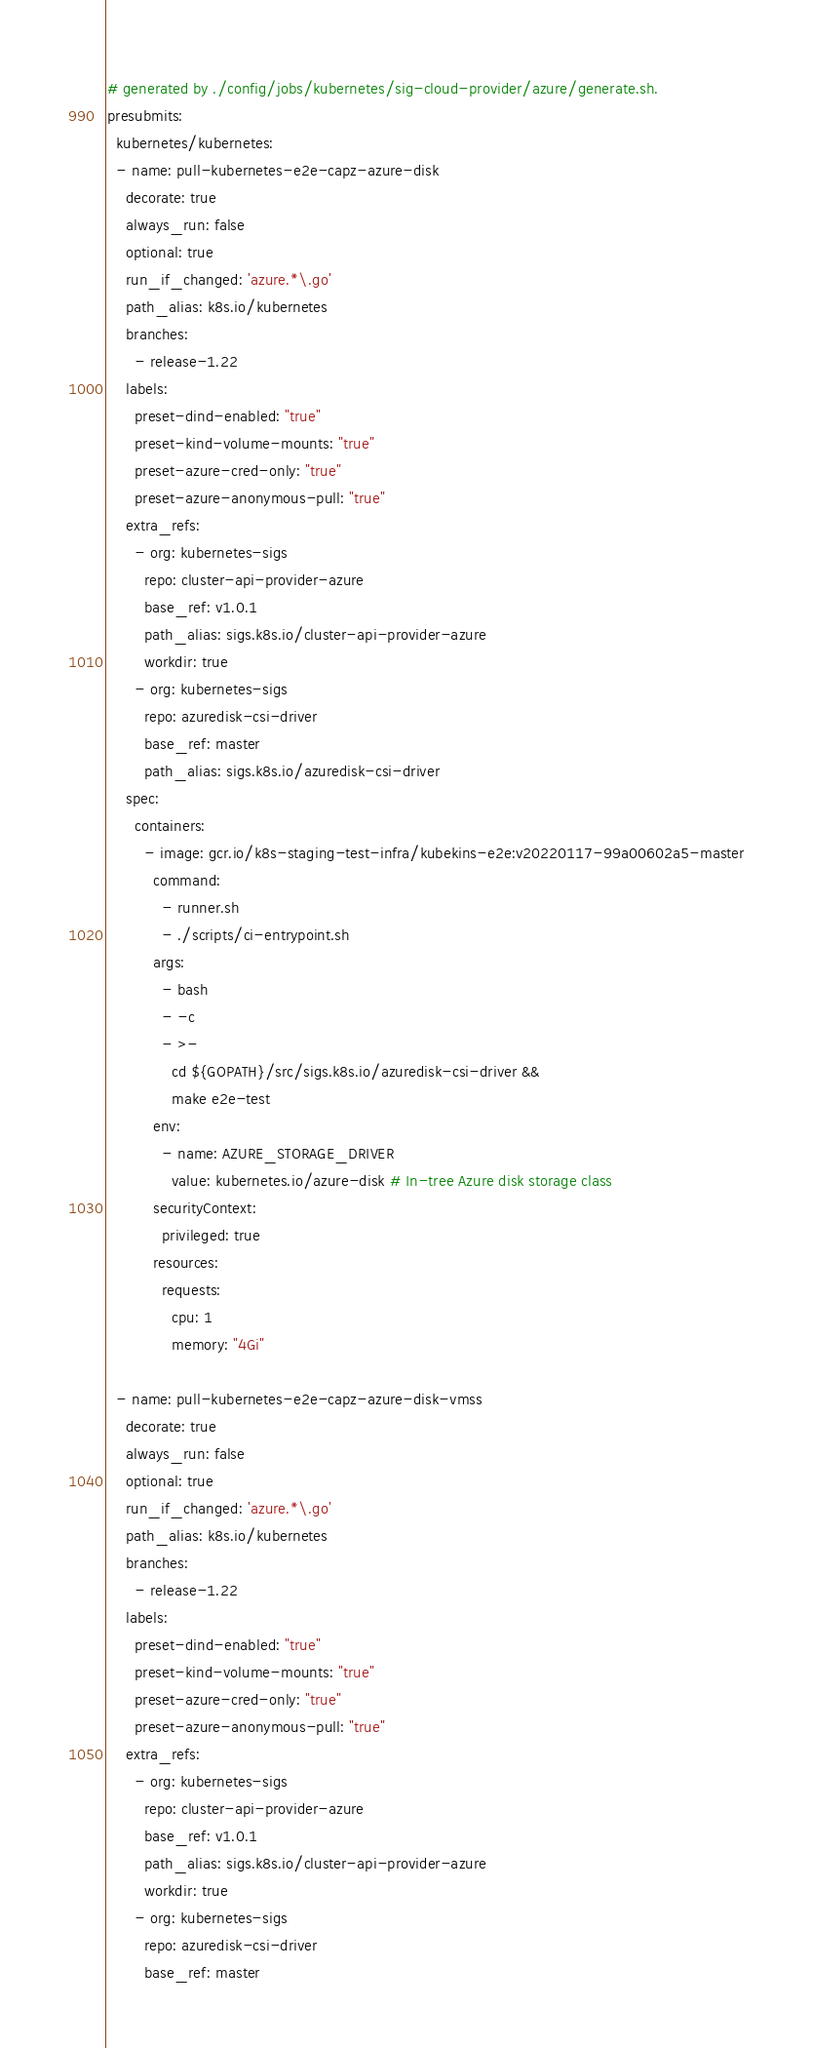<code> <loc_0><loc_0><loc_500><loc_500><_YAML_># generated by ./config/jobs/kubernetes/sig-cloud-provider/azure/generate.sh.
presubmits:
  kubernetes/kubernetes:
  - name: pull-kubernetes-e2e-capz-azure-disk
    decorate: true
    always_run: false
    optional: true
    run_if_changed: 'azure.*\.go'
    path_alias: k8s.io/kubernetes
    branches:
      - release-1.22
    labels:
      preset-dind-enabled: "true"
      preset-kind-volume-mounts: "true"
      preset-azure-cred-only: "true"
      preset-azure-anonymous-pull: "true"
    extra_refs:
      - org: kubernetes-sigs
        repo: cluster-api-provider-azure
        base_ref: v1.0.1
        path_alias: sigs.k8s.io/cluster-api-provider-azure
        workdir: true
      - org: kubernetes-sigs
        repo: azuredisk-csi-driver
        base_ref: master
        path_alias: sigs.k8s.io/azuredisk-csi-driver
    spec:
      containers:
        - image: gcr.io/k8s-staging-test-infra/kubekins-e2e:v20220117-99a00602a5-master
          command:
            - runner.sh
            - ./scripts/ci-entrypoint.sh
          args:
            - bash
            - -c
            - >-
              cd ${GOPATH}/src/sigs.k8s.io/azuredisk-csi-driver &&
              make e2e-test
          env:
            - name: AZURE_STORAGE_DRIVER
              value: kubernetes.io/azure-disk # In-tree Azure disk storage class
          securityContext:
            privileged: true
          resources:
            requests:
              cpu: 1
              memory: "4Gi"

  - name: pull-kubernetes-e2e-capz-azure-disk-vmss
    decorate: true
    always_run: false
    optional: true
    run_if_changed: 'azure.*\.go'
    path_alias: k8s.io/kubernetes
    branches:
      - release-1.22
    labels:
      preset-dind-enabled: "true"
      preset-kind-volume-mounts: "true"
      preset-azure-cred-only: "true"
      preset-azure-anonymous-pull: "true"
    extra_refs:
      - org: kubernetes-sigs
        repo: cluster-api-provider-azure
        base_ref: v1.0.1
        path_alias: sigs.k8s.io/cluster-api-provider-azure
        workdir: true
      - org: kubernetes-sigs
        repo: azuredisk-csi-driver
        base_ref: master</code> 